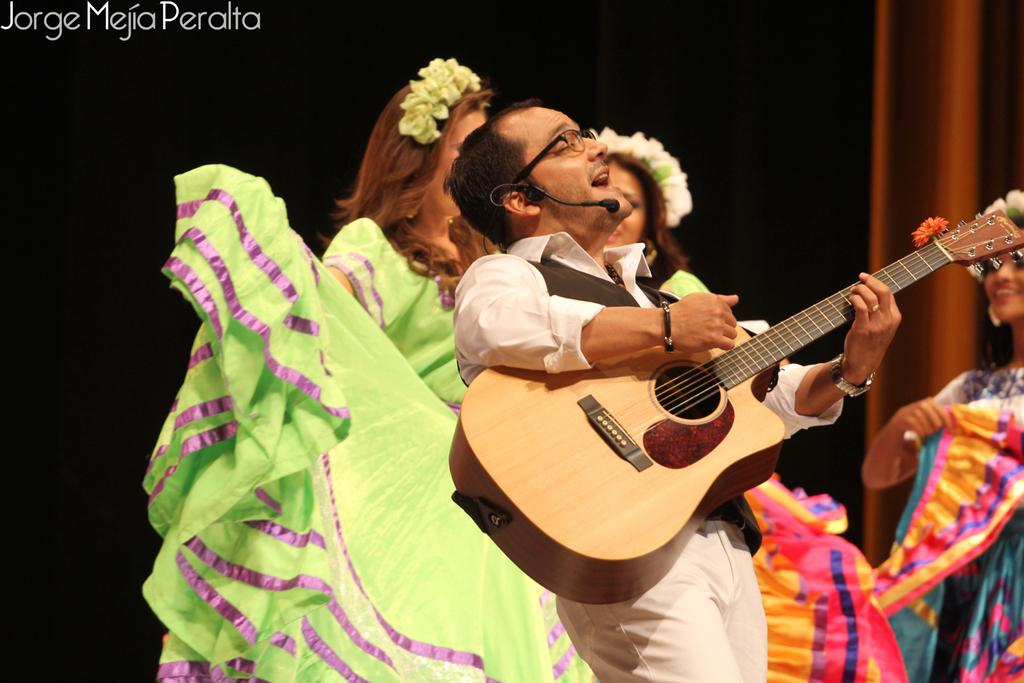What is the person holding in the image? The person is holding a camera in the image. What is the subject of the photograph being taken? The person is taking a picture of a mountain. What is the weather like in the image? The sky is clear, and there are clouds in the sky. What is the current price of the camera being used in the image? There is no information about the price of the camera in the image. Can you see any signs of the camera being burned in the image? There is no indication of the camera being burned in the image. 